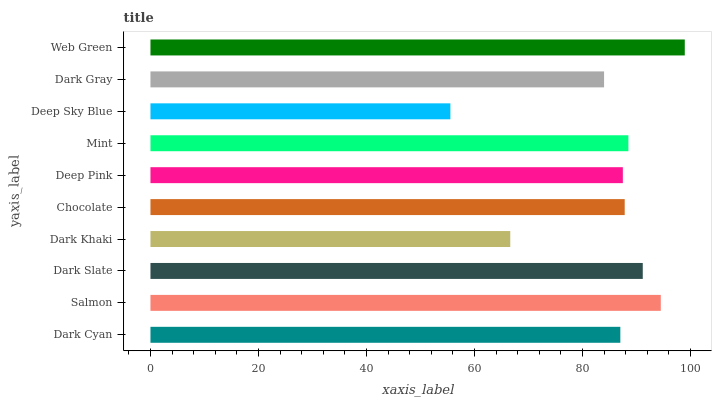Is Deep Sky Blue the minimum?
Answer yes or no. Yes. Is Web Green the maximum?
Answer yes or no. Yes. Is Salmon the minimum?
Answer yes or no. No. Is Salmon the maximum?
Answer yes or no. No. Is Salmon greater than Dark Cyan?
Answer yes or no. Yes. Is Dark Cyan less than Salmon?
Answer yes or no. Yes. Is Dark Cyan greater than Salmon?
Answer yes or no. No. Is Salmon less than Dark Cyan?
Answer yes or no. No. Is Chocolate the high median?
Answer yes or no. Yes. Is Deep Pink the low median?
Answer yes or no. Yes. Is Deep Sky Blue the high median?
Answer yes or no. No. Is Chocolate the low median?
Answer yes or no. No. 